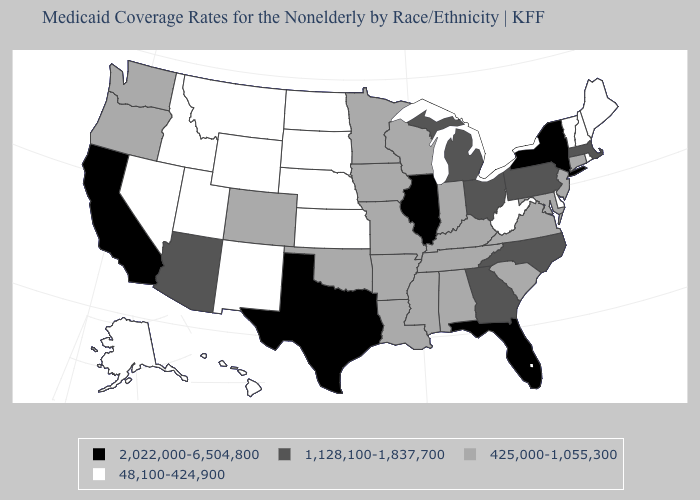Name the states that have a value in the range 425,000-1,055,300?
Write a very short answer. Alabama, Arkansas, Colorado, Connecticut, Indiana, Iowa, Kentucky, Louisiana, Maryland, Minnesota, Mississippi, Missouri, New Jersey, Oklahoma, Oregon, South Carolina, Tennessee, Virginia, Washington, Wisconsin. What is the lowest value in the USA?
Give a very brief answer. 48,100-424,900. Does the first symbol in the legend represent the smallest category?
Quick response, please. No. What is the value of Minnesota?
Quick response, please. 425,000-1,055,300. Which states have the highest value in the USA?
Short answer required. California, Florida, Illinois, New York, Texas. Does Pennsylvania have the lowest value in the USA?
Keep it brief. No. What is the value of South Dakota?
Quick response, please. 48,100-424,900. What is the highest value in the South ?
Quick response, please. 2,022,000-6,504,800. Does the first symbol in the legend represent the smallest category?
Give a very brief answer. No. Name the states that have a value in the range 48,100-424,900?
Short answer required. Alaska, Delaware, Hawaii, Idaho, Kansas, Maine, Montana, Nebraska, Nevada, New Hampshire, New Mexico, North Dakota, Rhode Island, South Dakota, Utah, Vermont, West Virginia, Wyoming. Name the states that have a value in the range 2,022,000-6,504,800?
Write a very short answer. California, Florida, Illinois, New York, Texas. Among the states that border Maryland , does Pennsylvania have the highest value?
Be succinct. Yes. What is the value of Pennsylvania?
Be succinct. 1,128,100-1,837,700. Does South Carolina have a higher value than Iowa?
Give a very brief answer. No. Name the states that have a value in the range 425,000-1,055,300?
Keep it brief. Alabama, Arkansas, Colorado, Connecticut, Indiana, Iowa, Kentucky, Louisiana, Maryland, Minnesota, Mississippi, Missouri, New Jersey, Oklahoma, Oregon, South Carolina, Tennessee, Virginia, Washington, Wisconsin. 